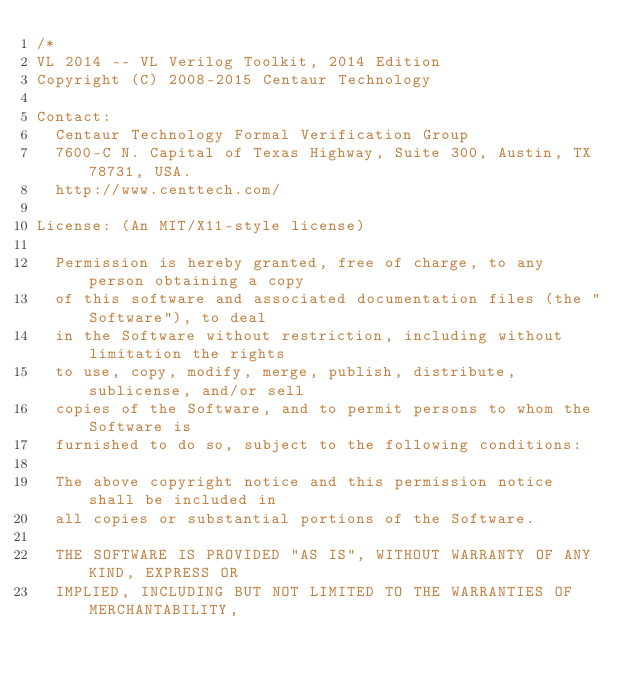<code> <loc_0><loc_0><loc_500><loc_500><_CSS_>/*
VL 2014 -- VL Verilog Toolkit, 2014 Edition
Copyright (C) 2008-2015 Centaur Technology

Contact:
  Centaur Technology Formal Verification Group
  7600-C N. Capital of Texas Highway, Suite 300, Austin, TX 78731, USA.
  http://www.centtech.com/

License: (An MIT/X11-style license)

  Permission is hereby granted, free of charge, to any person obtaining a copy
  of this software and associated documentation files (the "Software"), to deal
  in the Software without restriction, including without limitation the rights
  to use, copy, modify, merge, publish, distribute, sublicense, and/or sell
  copies of the Software, and to permit persons to whom the Software is
  furnished to do so, subject to the following conditions:

  The above copyright notice and this permission notice shall be included in
  all copies or substantial portions of the Software.

  THE SOFTWARE IS PROVIDED "AS IS", WITHOUT WARRANTY OF ANY KIND, EXPRESS OR
  IMPLIED, INCLUDING BUT NOT LIMITED TO THE WARRANTIES OF MERCHANTABILITY,</code> 